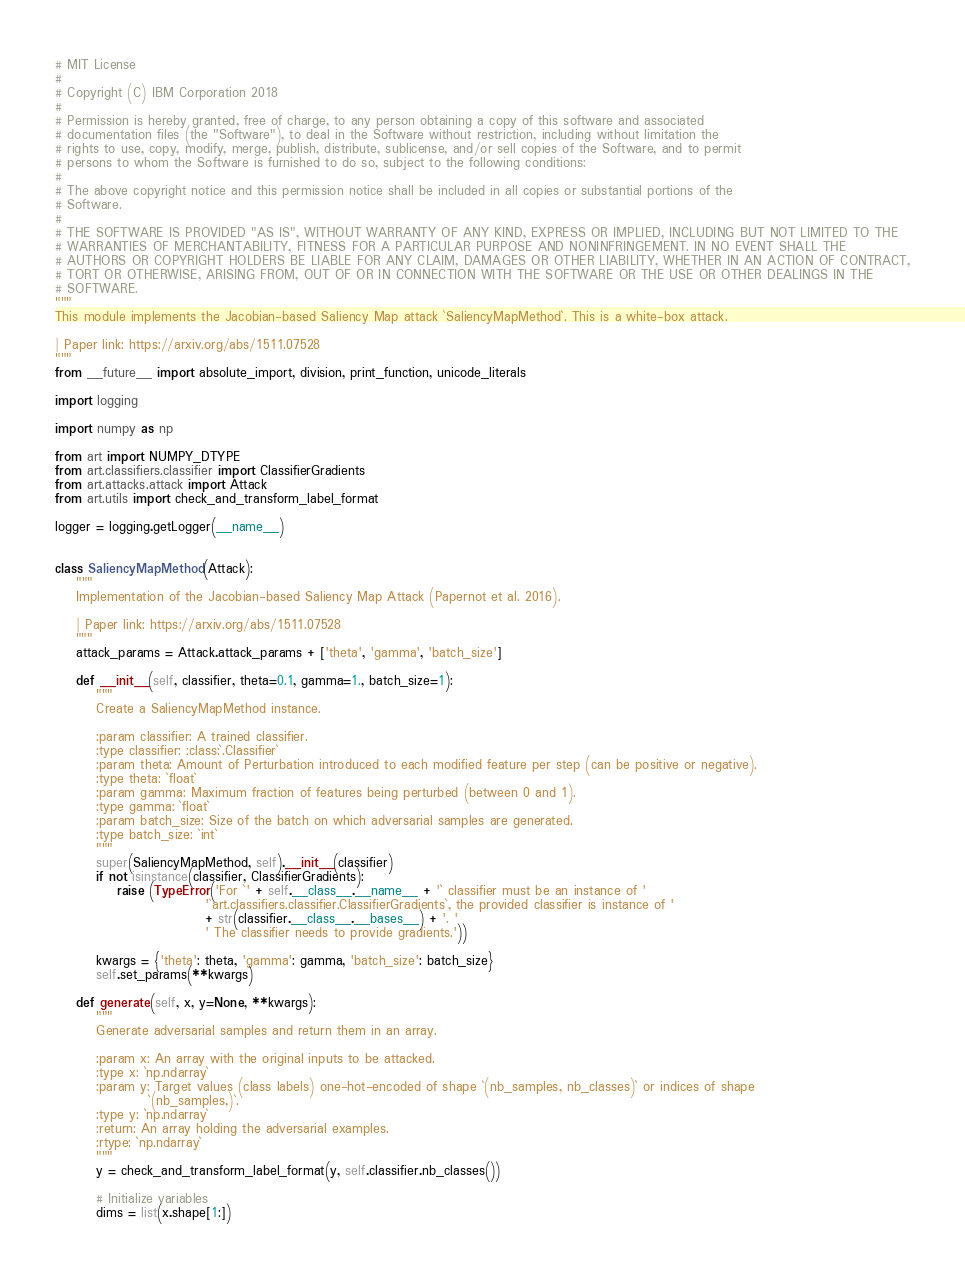Convert code to text. <code><loc_0><loc_0><loc_500><loc_500><_Python_># MIT License
#
# Copyright (C) IBM Corporation 2018
#
# Permission is hereby granted, free of charge, to any person obtaining a copy of this software and associated
# documentation files (the "Software"), to deal in the Software without restriction, including without limitation the
# rights to use, copy, modify, merge, publish, distribute, sublicense, and/or sell copies of the Software, and to permit
# persons to whom the Software is furnished to do so, subject to the following conditions:
#
# The above copyright notice and this permission notice shall be included in all copies or substantial portions of the
# Software.
#
# THE SOFTWARE IS PROVIDED "AS IS", WITHOUT WARRANTY OF ANY KIND, EXPRESS OR IMPLIED, INCLUDING BUT NOT LIMITED TO THE
# WARRANTIES OF MERCHANTABILITY, FITNESS FOR A PARTICULAR PURPOSE AND NONINFRINGEMENT. IN NO EVENT SHALL THE
# AUTHORS OR COPYRIGHT HOLDERS BE LIABLE FOR ANY CLAIM, DAMAGES OR OTHER LIABILITY, WHETHER IN AN ACTION OF CONTRACT,
# TORT OR OTHERWISE, ARISING FROM, OUT OF OR IN CONNECTION WITH THE SOFTWARE OR THE USE OR OTHER DEALINGS IN THE
# SOFTWARE.
"""
This module implements the Jacobian-based Saliency Map attack `SaliencyMapMethod`. This is a white-box attack.

| Paper link: https://arxiv.org/abs/1511.07528
"""
from __future__ import absolute_import, division, print_function, unicode_literals

import logging

import numpy as np

from art import NUMPY_DTYPE
from art.classifiers.classifier import ClassifierGradients
from art.attacks.attack import Attack
from art.utils import check_and_transform_label_format

logger = logging.getLogger(__name__)


class SaliencyMapMethod(Attack):
    """
    Implementation of the Jacobian-based Saliency Map Attack (Papernot et al. 2016).

    | Paper link: https://arxiv.org/abs/1511.07528
    """
    attack_params = Attack.attack_params + ['theta', 'gamma', 'batch_size']

    def __init__(self, classifier, theta=0.1, gamma=1., batch_size=1):
        """
        Create a SaliencyMapMethod instance.

        :param classifier: A trained classifier.
        :type classifier: :class:`.Classifier`
        :param theta: Amount of Perturbation introduced to each modified feature per step (can be positive or negative).
        :type theta: `float`
        :param gamma: Maximum fraction of features being perturbed (between 0 and 1).
        :type gamma: `float`
        :param batch_size: Size of the batch on which adversarial samples are generated.
        :type batch_size: `int`
        """
        super(SaliencyMapMethod, self).__init__(classifier)
        if not isinstance(classifier, ClassifierGradients):
            raise (TypeError('For `' + self.__class__.__name__ + '` classifier must be an instance of '
                             '`art.classifiers.classifier.ClassifierGradients`, the provided classifier is instance of '
                             + str(classifier.__class__.__bases__) + '. '
                             ' The classifier needs to provide gradients.'))

        kwargs = {'theta': theta, 'gamma': gamma, 'batch_size': batch_size}
        self.set_params(**kwargs)

    def generate(self, x, y=None, **kwargs):
        """
        Generate adversarial samples and return them in an array.

        :param x: An array with the original inputs to be attacked.
        :type x: `np.ndarray`
        :param y: Target values (class labels) one-hot-encoded of shape `(nb_samples, nb_classes)` or indices of shape
                  `(nb_samples,)`.
        :type y: `np.ndarray`
        :return: An array holding the adversarial examples.
        :rtype: `np.ndarray`
        """
        y = check_and_transform_label_format(y, self.classifier.nb_classes())

        # Initialize variables
        dims = list(x.shape[1:])</code> 